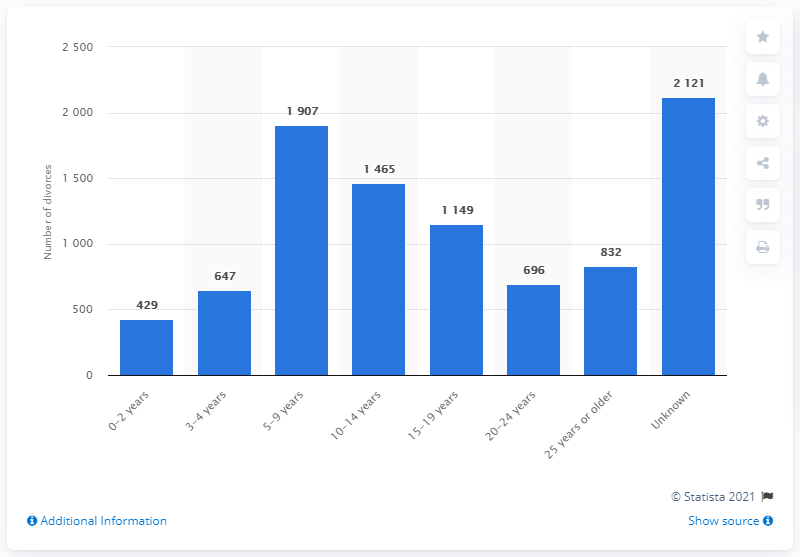Outline some significant characteristics in this image. There were 832 married couples who got divorced after 25 years or more of marriage. 